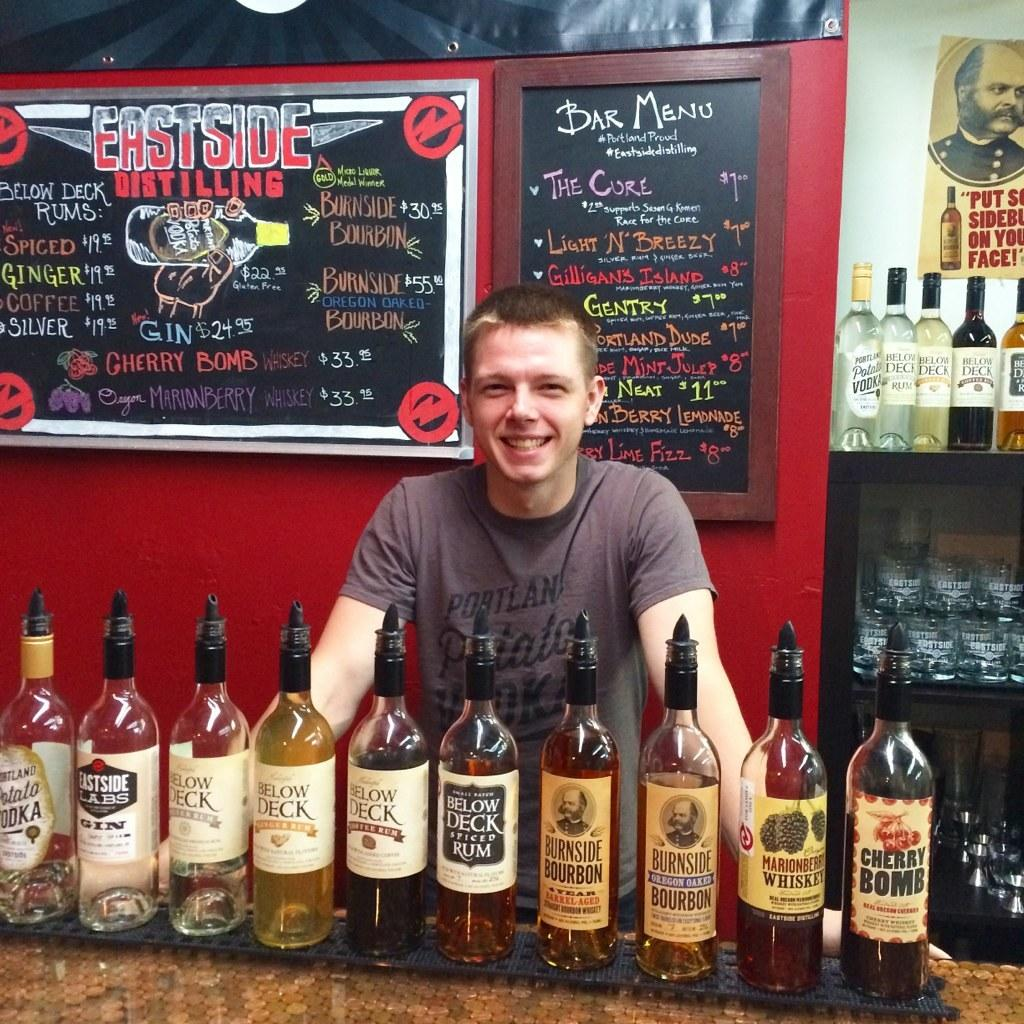<image>
Describe the image concisely. A man standing at East Side Distilling with liquor in bottles 